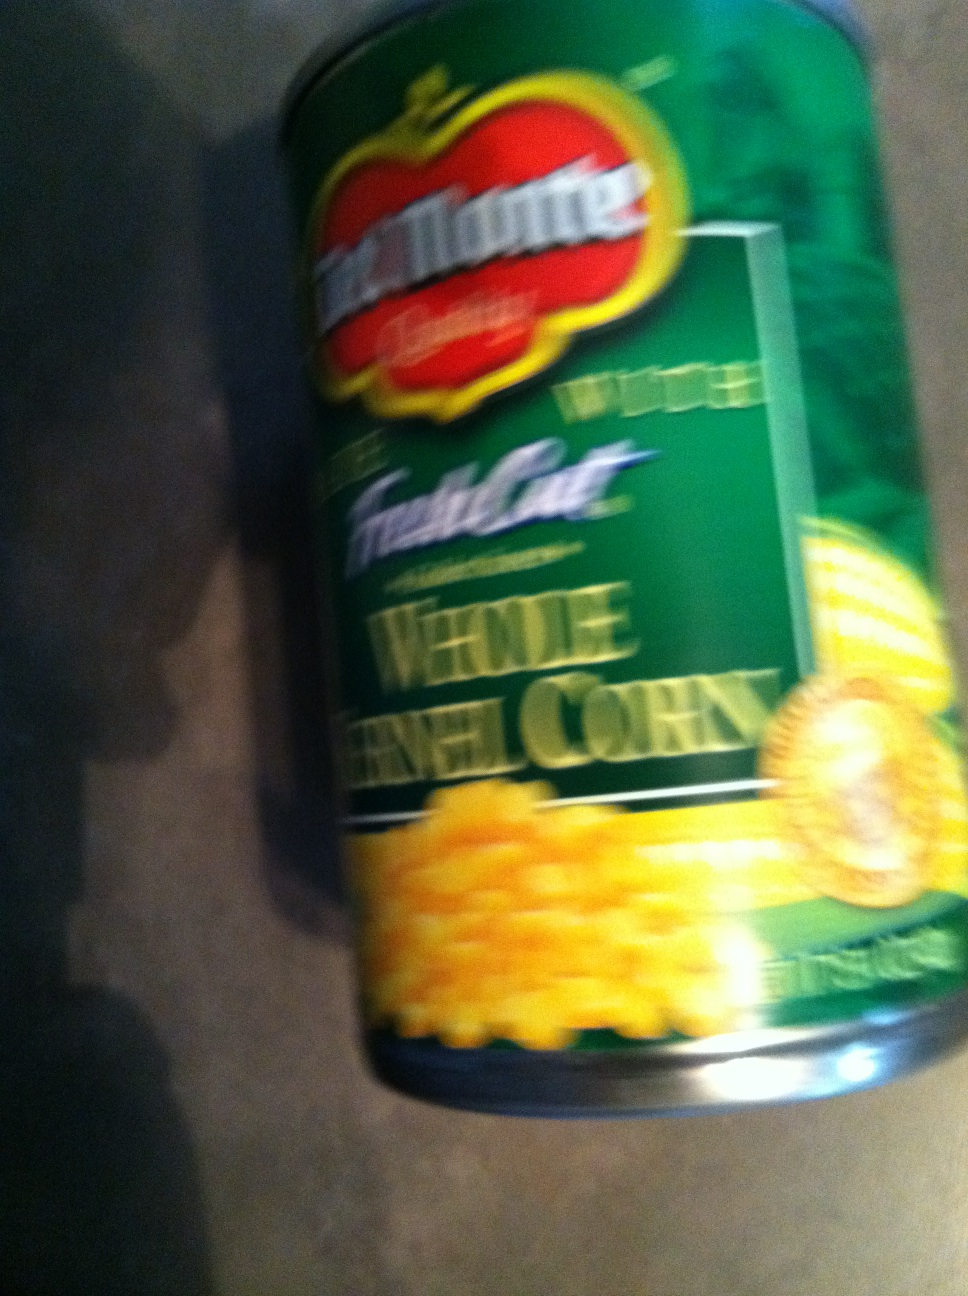What kind of soup is this? The image depicts a can of 'Del Monte Fresh Cut Whole Kernel Corn', so it does not show any type of soup. It seems there might have been some confusion; this is a canned vegetable product, not soup. 